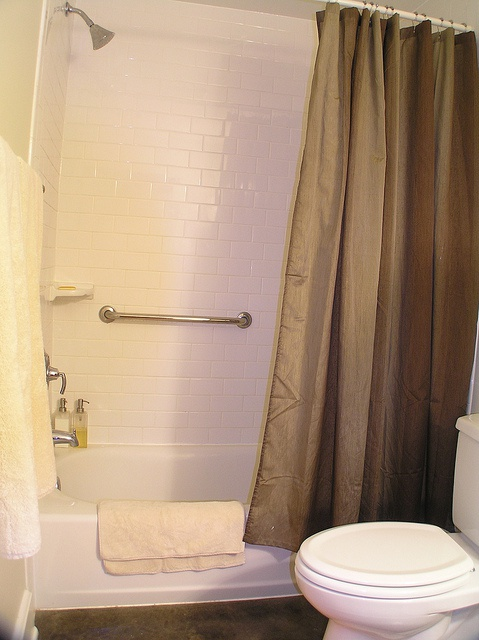Describe the objects in this image and their specific colors. I can see toilet in tan, lightgray, darkgray, and pink tones, bottle in tan tones, and bottle in tan tones in this image. 